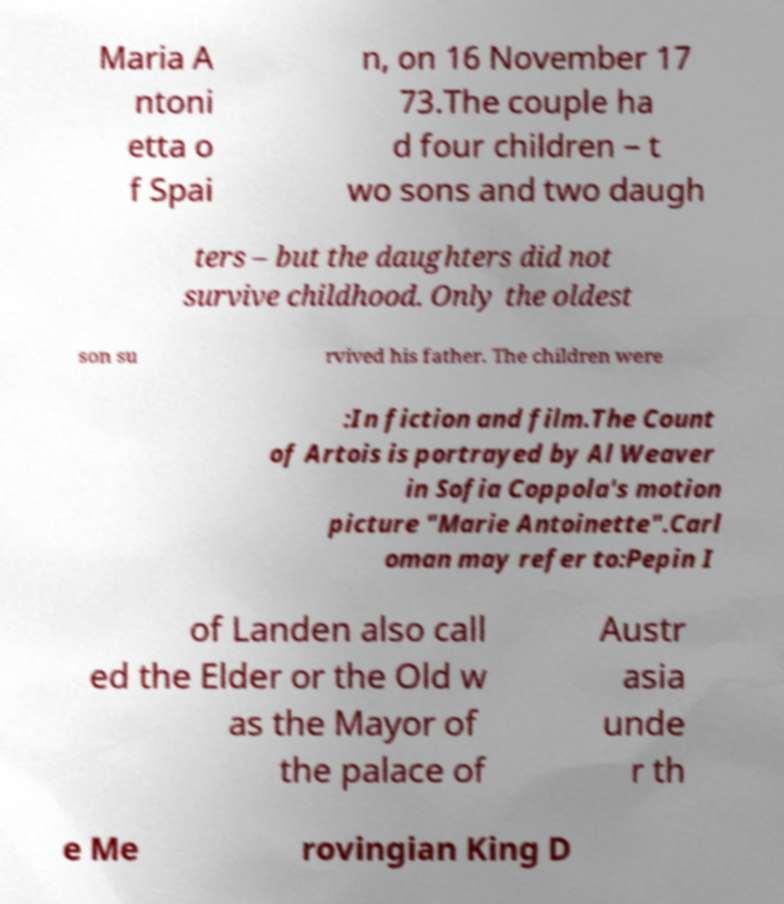Could you extract and type out the text from this image? Maria A ntoni etta o f Spai n, on 16 November 17 73.The couple ha d four children – t wo sons and two daugh ters – but the daughters did not survive childhood. Only the oldest son su rvived his father. The children were :In fiction and film.The Count of Artois is portrayed by Al Weaver in Sofia Coppola's motion picture "Marie Antoinette".Carl oman may refer to:Pepin I of Landen also call ed the Elder or the Old w as the Mayor of the palace of Austr asia unde r th e Me rovingian King D 